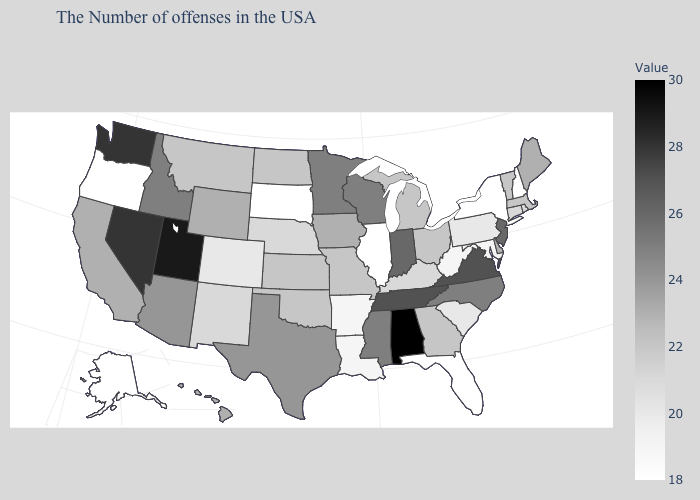Among the states that border Maryland , does Virginia have the highest value?
Write a very short answer. Yes. Which states have the lowest value in the West?
Write a very short answer. Oregon, Alaska. Which states have the lowest value in the USA?
Quick response, please. New Hampshire, New York, Florida, Illinois, South Dakota, Oregon, Alaska. Is the legend a continuous bar?
Give a very brief answer. Yes. Among the states that border Nevada , does Oregon have the highest value?
Keep it brief. No. Does New Jersey have the highest value in the Northeast?
Short answer required. Yes. 